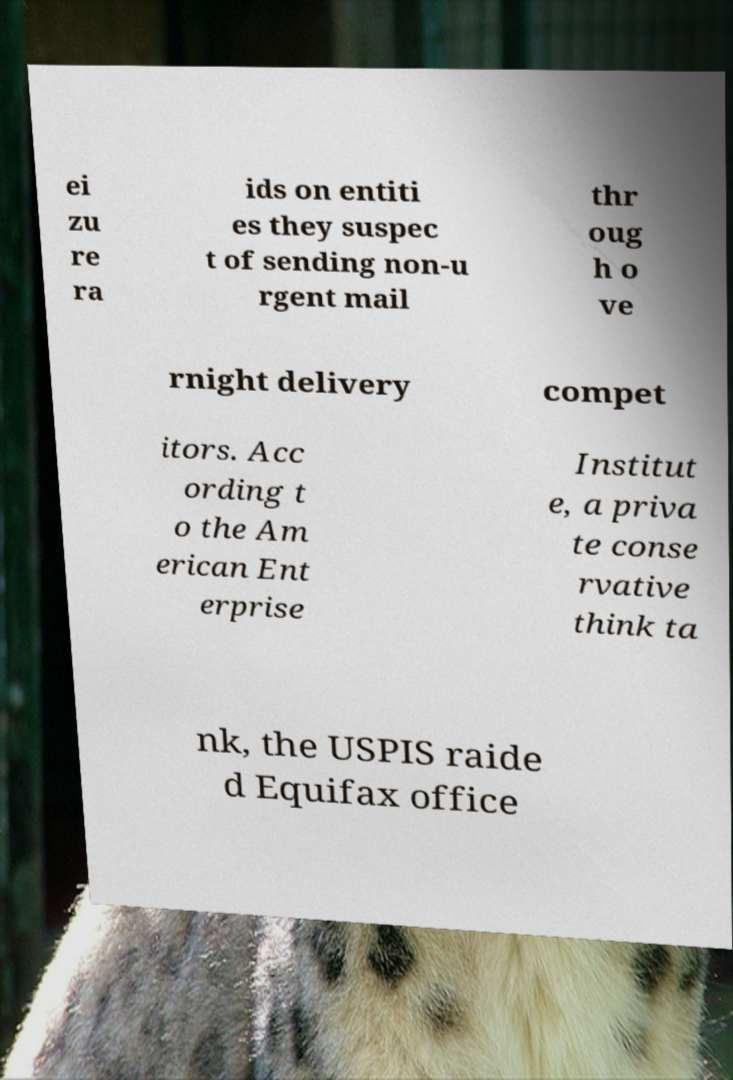Please read and relay the text visible in this image. What does it say? ei zu re ra ids on entiti es they suspec t of sending non-u rgent mail thr oug h o ve rnight delivery compet itors. Acc ording t o the Am erican Ent erprise Institut e, a priva te conse rvative think ta nk, the USPIS raide d Equifax office 